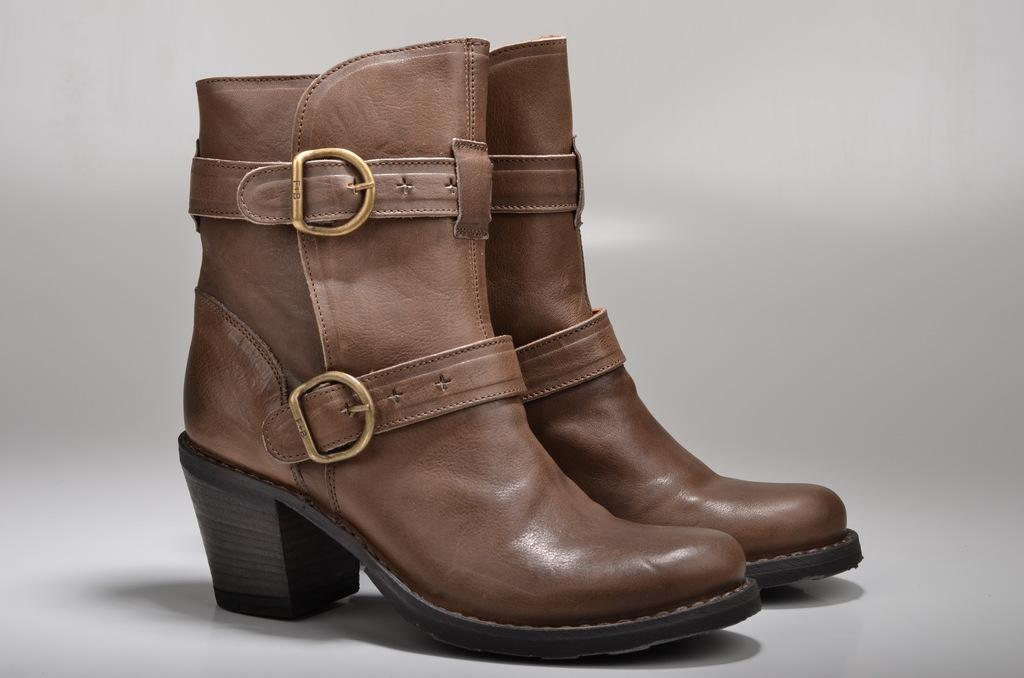What type of objects can be seen in the image? There are shoes in the image. Can you describe the background of the image? The background of the image is a grey and white color image. What type of cork can be seen in the image? There is no cork present in the image; it only features shoes and a grey and white color image in the background. 